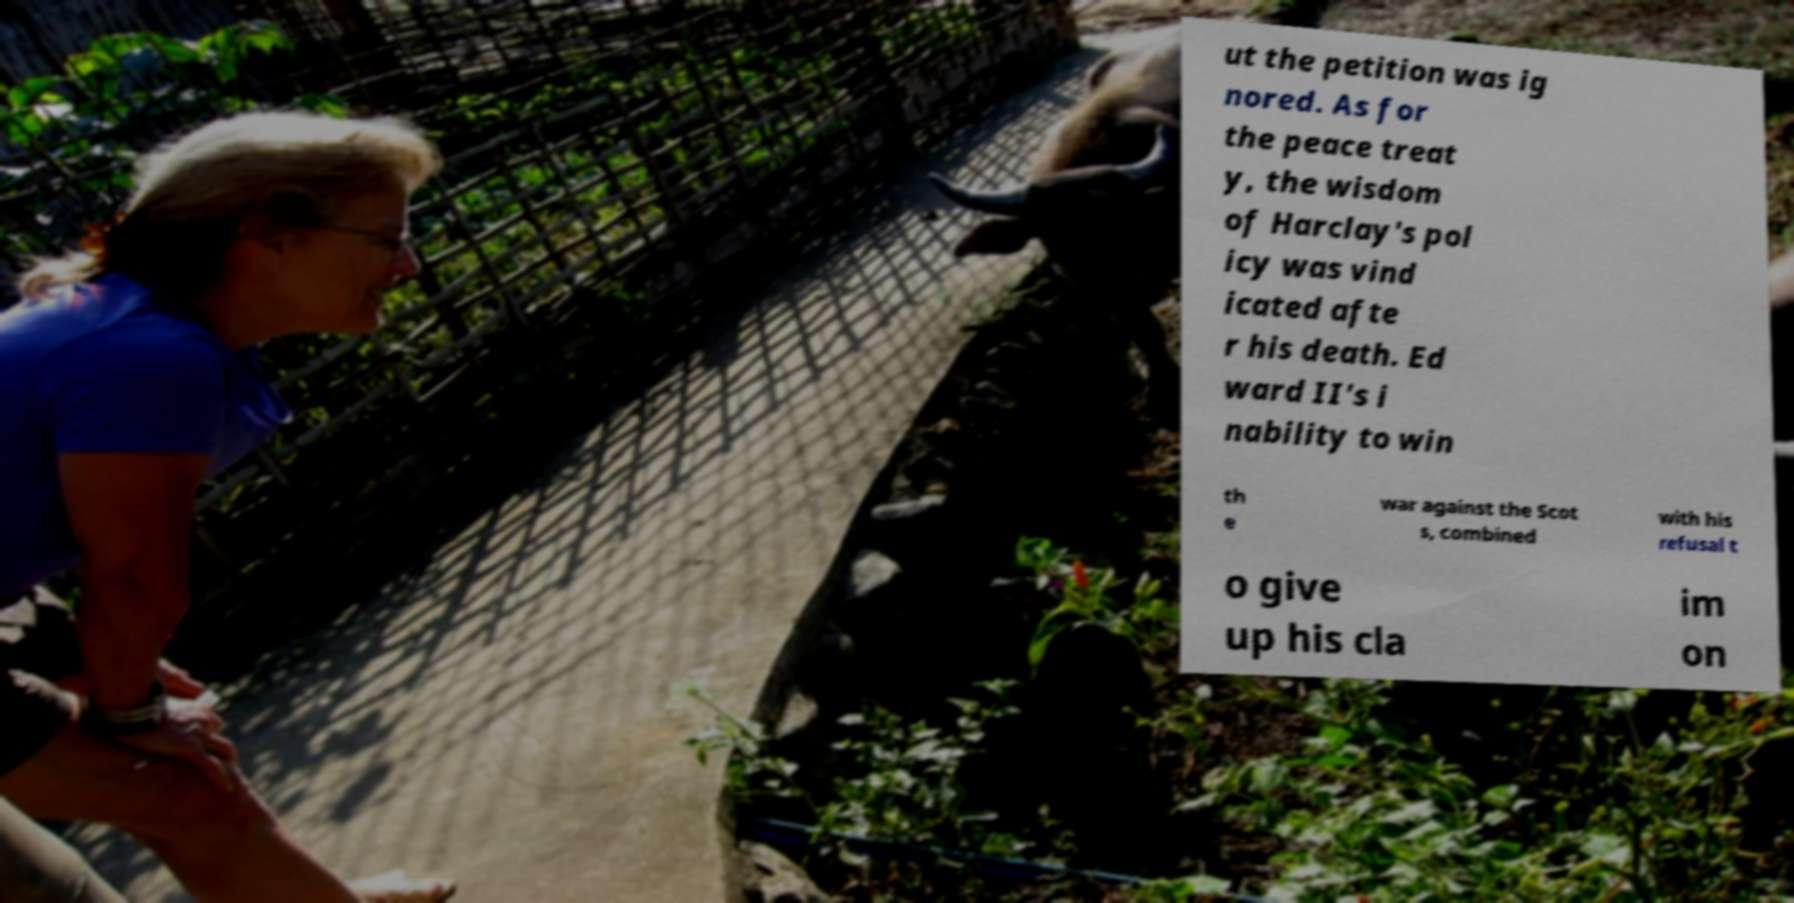I need the written content from this picture converted into text. Can you do that? ut the petition was ig nored. As for the peace treat y, the wisdom of Harclay's pol icy was vind icated afte r his death. Ed ward II's i nability to win th e war against the Scot s, combined with his refusal t o give up his cla im on 